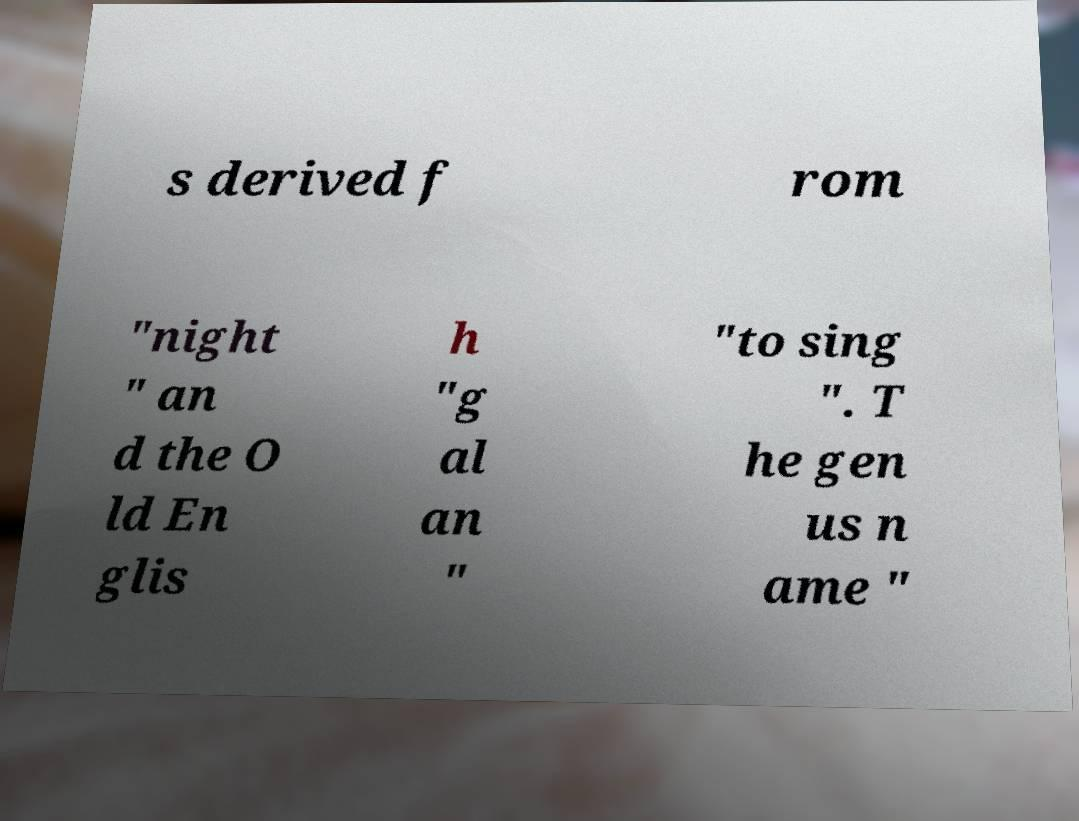Please identify and transcribe the text found in this image. s derived f rom "night " an d the O ld En glis h "g al an " "to sing ". T he gen us n ame " 